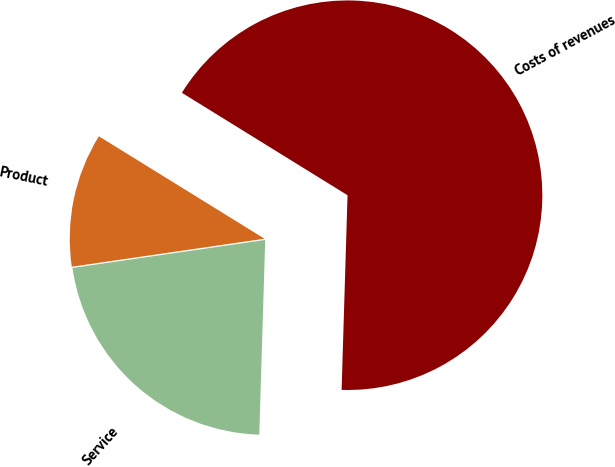Convert chart. <chart><loc_0><loc_0><loc_500><loc_500><pie_chart><fcel>Product<fcel>Service<fcel>Costs of revenues<nl><fcel>11.11%<fcel>22.22%<fcel>66.67%<nl></chart> 